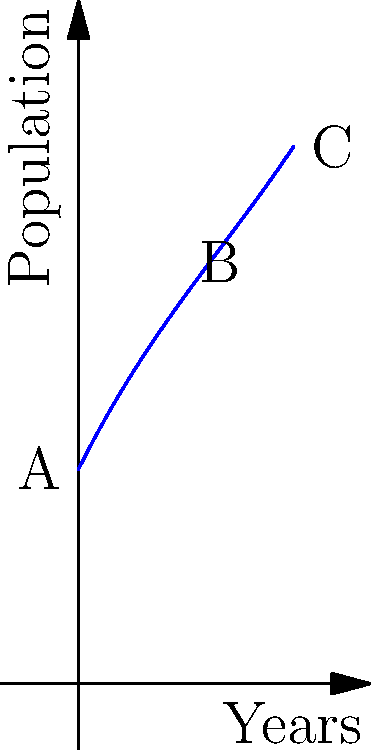The graph shows the population growth of an endangered bird species over a 10-year period. If the current conservation efforts continue, what will be the approximate rate of population change (birds per year) between years 5 and 10? To find the rate of population change between years 5 and 10:

1. Identify the population at year 5 (point B) and year 10 (point C).
   Year 5 (B): Approximately 22 birds
   Year 10 (C): Approximately 32 birds

2. Calculate the change in population:
   $\Delta \text{Population} = 32 - 22 = 10$ birds

3. Calculate the time interval:
   $\Delta \text{Time} = 10 - 5 = 5$ years

4. Calculate the rate of change:
   Rate = $\frac{\Delta \text{Population}}{\Delta \text{Time}} = \frac{10 \text{ birds}}{5 \text{ years}} = 2 \text{ birds per year}$

The rate of population change between years 5 and 10 is approximately 2 birds per year.
Answer: 2 birds per year 